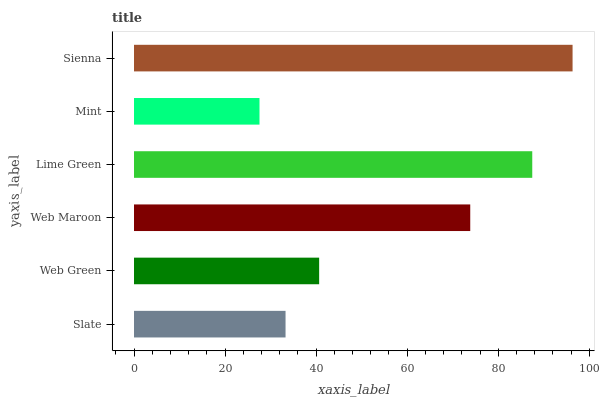Is Mint the minimum?
Answer yes or no. Yes. Is Sienna the maximum?
Answer yes or no. Yes. Is Web Green the minimum?
Answer yes or no. No. Is Web Green the maximum?
Answer yes or no. No. Is Web Green greater than Slate?
Answer yes or no. Yes. Is Slate less than Web Green?
Answer yes or no. Yes. Is Slate greater than Web Green?
Answer yes or no. No. Is Web Green less than Slate?
Answer yes or no. No. Is Web Maroon the high median?
Answer yes or no. Yes. Is Web Green the low median?
Answer yes or no. Yes. Is Slate the high median?
Answer yes or no. No. Is Sienna the low median?
Answer yes or no. No. 